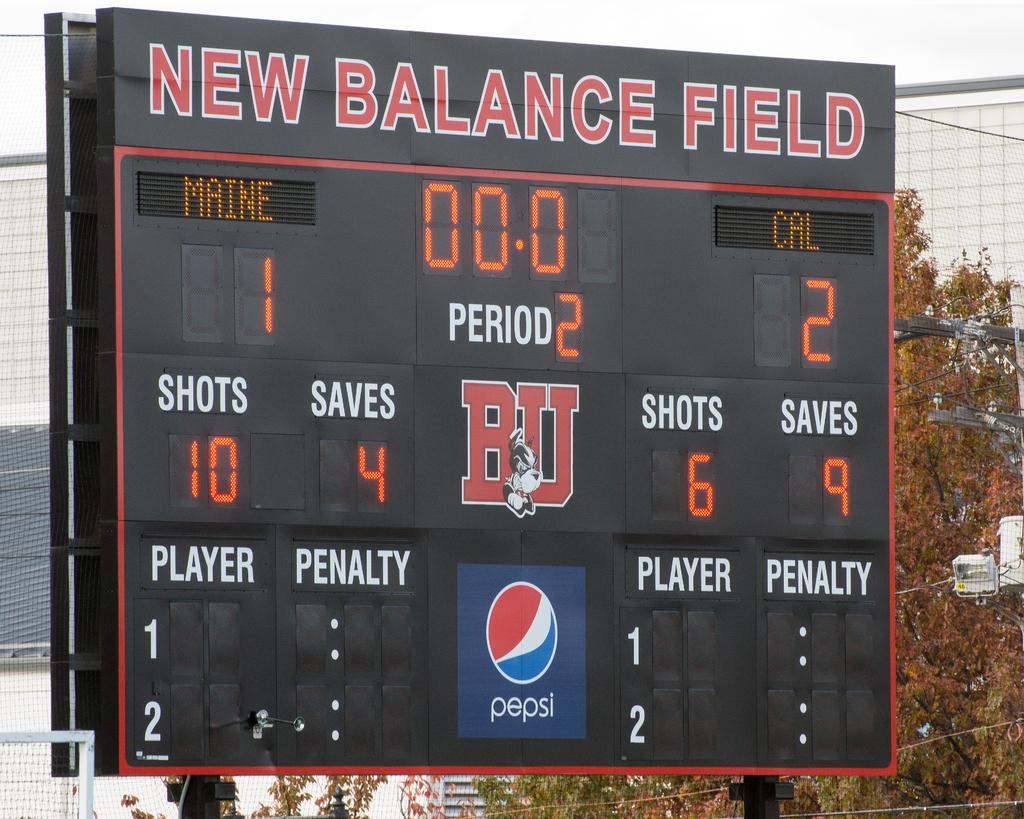<image>
Relay a brief, clear account of the picture shown. Scoreboard for New Balance Field with an ad for Pepsi. 